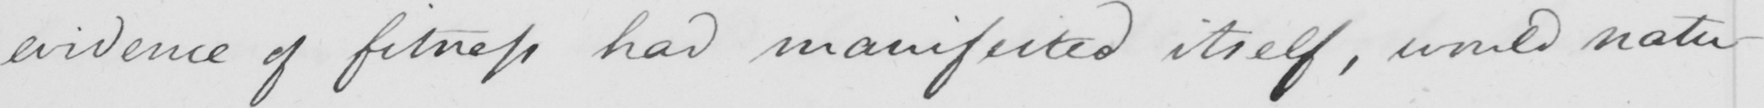What text is written in this handwritten line? evidence of fitness had manifested itself , would natu- 